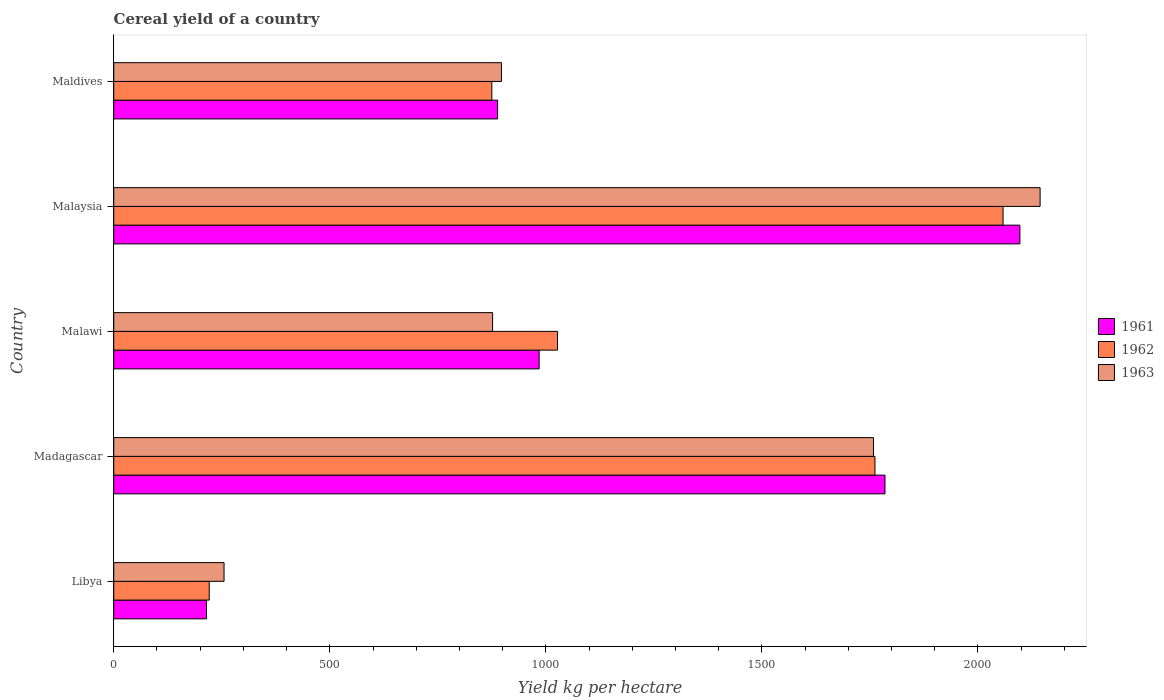How many groups of bars are there?
Make the answer very short. 5. How many bars are there on the 3rd tick from the top?
Offer a very short reply. 3. How many bars are there on the 5th tick from the bottom?
Your response must be concise. 3. What is the label of the 5th group of bars from the top?
Offer a terse response. Libya. In how many cases, is the number of bars for a given country not equal to the number of legend labels?
Provide a succinct answer. 0. What is the total cereal yield in 1962 in Maldives?
Ensure brevity in your answer.  875. Across all countries, what is the maximum total cereal yield in 1962?
Provide a short and direct response. 2058.06. Across all countries, what is the minimum total cereal yield in 1963?
Offer a very short reply. 255.27. In which country was the total cereal yield in 1962 maximum?
Give a very brief answer. Malaysia. In which country was the total cereal yield in 1961 minimum?
Ensure brevity in your answer.  Libya. What is the total total cereal yield in 1962 in the graph?
Your response must be concise. 5942.66. What is the difference between the total cereal yield in 1962 in Libya and that in Malaysia?
Offer a terse response. -1837.1. What is the difference between the total cereal yield in 1963 in Malawi and the total cereal yield in 1962 in Libya?
Your answer should be compact. 655.77. What is the average total cereal yield in 1962 per country?
Give a very brief answer. 1188.53. What is the difference between the total cereal yield in 1961 and total cereal yield in 1962 in Maldives?
Make the answer very short. 13.27. What is the ratio of the total cereal yield in 1962 in Libya to that in Maldives?
Make the answer very short. 0.25. Is the difference between the total cereal yield in 1961 in Madagascar and Maldives greater than the difference between the total cereal yield in 1962 in Madagascar and Maldives?
Ensure brevity in your answer.  Yes. What is the difference between the highest and the second highest total cereal yield in 1963?
Offer a terse response. 385.6. What is the difference between the highest and the lowest total cereal yield in 1963?
Keep it short and to the point. 1888.54. In how many countries, is the total cereal yield in 1963 greater than the average total cereal yield in 1963 taken over all countries?
Offer a very short reply. 2. Are all the bars in the graph horizontal?
Offer a terse response. Yes. How many countries are there in the graph?
Give a very brief answer. 5. What is the difference between two consecutive major ticks on the X-axis?
Your answer should be compact. 500. Does the graph contain any zero values?
Make the answer very short. No. Does the graph contain grids?
Offer a terse response. No. How many legend labels are there?
Keep it short and to the point. 3. What is the title of the graph?
Ensure brevity in your answer.  Cereal yield of a country. Does "1985" appear as one of the legend labels in the graph?
Your answer should be very brief. No. What is the label or title of the X-axis?
Keep it short and to the point. Yield kg per hectare. What is the Yield kg per hectare of 1961 in Libya?
Provide a succinct answer. 214.71. What is the Yield kg per hectare of 1962 in Libya?
Make the answer very short. 220.96. What is the Yield kg per hectare of 1963 in Libya?
Your response must be concise. 255.27. What is the Yield kg per hectare of 1961 in Madagascar?
Offer a terse response. 1784.82. What is the Yield kg per hectare in 1962 in Madagascar?
Your response must be concise. 1761.64. What is the Yield kg per hectare in 1963 in Madagascar?
Provide a succinct answer. 1758.21. What is the Yield kg per hectare in 1961 in Malawi?
Make the answer very short. 984.46. What is the Yield kg per hectare in 1962 in Malawi?
Offer a very short reply. 1027. What is the Yield kg per hectare of 1963 in Malawi?
Make the answer very short. 876.73. What is the Yield kg per hectare of 1961 in Malaysia?
Your response must be concise. 2097.04. What is the Yield kg per hectare of 1962 in Malaysia?
Make the answer very short. 2058.06. What is the Yield kg per hectare in 1963 in Malaysia?
Make the answer very short. 2143.81. What is the Yield kg per hectare in 1961 in Maldives?
Offer a terse response. 888.27. What is the Yield kg per hectare in 1962 in Maldives?
Provide a succinct answer. 875. What is the Yield kg per hectare of 1963 in Maldives?
Your answer should be very brief. 897.26. Across all countries, what is the maximum Yield kg per hectare of 1961?
Provide a succinct answer. 2097.04. Across all countries, what is the maximum Yield kg per hectare in 1962?
Keep it short and to the point. 2058.06. Across all countries, what is the maximum Yield kg per hectare of 1963?
Your response must be concise. 2143.81. Across all countries, what is the minimum Yield kg per hectare of 1961?
Ensure brevity in your answer.  214.71. Across all countries, what is the minimum Yield kg per hectare of 1962?
Provide a short and direct response. 220.96. Across all countries, what is the minimum Yield kg per hectare in 1963?
Keep it short and to the point. 255.27. What is the total Yield kg per hectare of 1961 in the graph?
Offer a very short reply. 5969.3. What is the total Yield kg per hectare of 1962 in the graph?
Provide a succinct answer. 5942.66. What is the total Yield kg per hectare of 1963 in the graph?
Keep it short and to the point. 5931.27. What is the difference between the Yield kg per hectare in 1961 in Libya and that in Madagascar?
Provide a short and direct response. -1570.11. What is the difference between the Yield kg per hectare in 1962 in Libya and that in Madagascar?
Your answer should be compact. -1540.68. What is the difference between the Yield kg per hectare in 1963 in Libya and that in Madagascar?
Keep it short and to the point. -1502.94. What is the difference between the Yield kg per hectare of 1961 in Libya and that in Malawi?
Keep it short and to the point. -769.75. What is the difference between the Yield kg per hectare of 1962 in Libya and that in Malawi?
Make the answer very short. -806.04. What is the difference between the Yield kg per hectare in 1963 in Libya and that in Malawi?
Ensure brevity in your answer.  -621.46. What is the difference between the Yield kg per hectare of 1961 in Libya and that in Malaysia?
Offer a very short reply. -1882.34. What is the difference between the Yield kg per hectare of 1962 in Libya and that in Malaysia?
Keep it short and to the point. -1837.11. What is the difference between the Yield kg per hectare of 1963 in Libya and that in Malaysia?
Offer a terse response. -1888.54. What is the difference between the Yield kg per hectare of 1961 in Libya and that in Maldives?
Provide a succinct answer. -673.56. What is the difference between the Yield kg per hectare of 1962 in Libya and that in Maldives?
Keep it short and to the point. -654.04. What is the difference between the Yield kg per hectare of 1963 in Libya and that in Maldives?
Your answer should be compact. -641.99. What is the difference between the Yield kg per hectare of 1961 in Madagascar and that in Malawi?
Keep it short and to the point. 800.36. What is the difference between the Yield kg per hectare in 1962 in Madagascar and that in Malawi?
Your answer should be compact. 734.64. What is the difference between the Yield kg per hectare of 1963 in Madagascar and that in Malawi?
Make the answer very short. 881.48. What is the difference between the Yield kg per hectare of 1961 in Madagascar and that in Malaysia?
Your response must be concise. -312.22. What is the difference between the Yield kg per hectare in 1962 in Madagascar and that in Malaysia?
Provide a succinct answer. -296.43. What is the difference between the Yield kg per hectare in 1963 in Madagascar and that in Malaysia?
Provide a short and direct response. -385.6. What is the difference between the Yield kg per hectare of 1961 in Madagascar and that in Maldives?
Offer a terse response. 896.55. What is the difference between the Yield kg per hectare in 1962 in Madagascar and that in Maldives?
Keep it short and to the point. 886.64. What is the difference between the Yield kg per hectare in 1963 in Madagascar and that in Maldives?
Provide a short and direct response. 860.95. What is the difference between the Yield kg per hectare of 1961 in Malawi and that in Malaysia?
Provide a short and direct response. -1112.58. What is the difference between the Yield kg per hectare in 1962 in Malawi and that in Malaysia?
Make the answer very short. -1031.07. What is the difference between the Yield kg per hectare of 1963 in Malawi and that in Malaysia?
Ensure brevity in your answer.  -1267.08. What is the difference between the Yield kg per hectare of 1961 in Malawi and that in Maldives?
Make the answer very short. 96.19. What is the difference between the Yield kg per hectare in 1962 in Malawi and that in Maldives?
Your response must be concise. 152. What is the difference between the Yield kg per hectare of 1963 in Malawi and that in Maldives?
Your response must be concise. -20.53. What is the difference between the Yield kg per hectare in 1961 in Malaysia and that in Maldives?
Offer a very short reply. 1208.78. What is the difference between the Yield kg per hectare of 1962 in Malaysia and that in Maldives?
Your response must be concise. 1183.06. What is the difference between the Yield kg per hectare of 1963 in Malaysia and that in Maldives?
Your answer should be very brief. 1246.55. What is the difference between the Yield kg per hectare in 1961 in Libya and the Yield kg per hectare in 1962 in Madagascar?
Your answer should be compact. -1546.93. What is the difference between the Yield kg per hectare in 1961 in Libya and the Yield kg per hectare in 1963 in Madagascar?
Provide a short and direct response. -1543.5. What is the difference between the Yield kg per hectare in 1962 in Libya and the Yield kg per hectare in 1963 in Madagascar?
Offer a terse response. -1537.25. What is the difference between the Yield kg per hectare of 1961 in Libya and the Yield kg per hectare of 1962 in Malawi?
Offer a very short reply. -812.29. What is the difference between the Yield kg per hectare in 1961 in Libya and the Yield kg per hectare in 1963 in Malawi?
Keep it short and to the point. -662.02. What is the difference between the Yield kg per hectare in 1962 in Libya and the Yield kg per hectare in 1963 in Malawi?
Offer a terse response. -655.77. What is the difference between the Yield kg per hectare in 1961 in Libya and the Yield kg per hectare in 1962 in Malaysia?
Ensure brevity in your answer.  -1843.36. What is the difference between the Yield kg per hectare in 1961 in Libya and the Yield kg per hectare in 1963 in Malaysia?
Provide a succinct answer. -1929.1. What is the difference between the Yield kg per hectare in 1962 in Libya and the Yield kg per hectare in 1963 in Malaysia?
Provide a succinct answer. -1922.85. What is the difference between the Yield kg per hectare of 1961 in Libya and the Yield kg per hectare of 1962 in Maldives?
Provide a short and direct response. -660.29. What is the difference between the Yield kg per hectare of 1961 in Libya and the Yield kg per hectare of 1963 in Maldives?
Provide a succinct answer. -682.55. What is the difference between the Yield kg per hectare of 1962 in Libya and the Yield kg per hectare of 1963 in Maldives?
Offer a terse response. -676.3. What is the difference between the Yield kg per hectare in 1961 in Madagascar and the Yield kg per hectare in 1962 in Malawi?
Offer a very short reply. 757.82. What is the difference between the Yield kg per hectare of 1961 in Madagascar and the Yield kg per hectare of 1963 in Malawi?
Offer a terse response. 908.09. What is the difference between the Yield kg per hectare in 1962 in Madagascar and the Yield kg per hectare in 1963 in Malawi?
Provide a succinct answer. 884.91. What is the difference between the Yield kg per hectare of 1961 in Madagascar and the Yield kg per hectare of 1962 in Malaysia?
Your answer should be very brief. -273.24. What is the difference between the Yield kg per hectare of 1961 in Madagascar and the Yield kg per hectare of 1963 in Malaysia?
Your answer should be very brief. -358.99. What is the difference between the Yield kg per hectare of 1962 in Madagascar and the Yield kg per hectare of 1963 in Malaysia?
Keep it short and to the point. -382.17. What is the difference between the Yield kg per hectare of 1961 in Madagascar and the Yield kg per hectare of 1962 in Maldives?
Your answer should be very brief. 909.82. What is the difference between the Yield kg per hectare of 1961 in Madagascar and the Yield kg per hectare of 1963 in Maldives?
Provide a short and direct response. 887.56. What is the difference between the Yield kg per hectare in 1962 in Madagascar and the Yield kg per hectare in 1963 in Maldives?
Your answer should be very brief. 864.38. What is the difference between the Yield kg per hectare of 1961 in Malawi and the Yield kg per hectare of 1962 in Malaysia?
Keep it short and to the point. -1073.6. What is the difference between the Yield kg per hectare in 1961 in Malawi and the Yield kg per hectare in 1963 in Malaysia?
Your answer should be compact. -1159.35. What is the difference between the Yield kg per hectare in 1962 in Malawi and the Yield kg per hectare in 1963 in Malaysia?
Make the answer very short. -1116.81. What is the difference between the Yield kg per hectare of 1961 in Malawi and the Yield kg per hectare of 1962 in Maldives?
Provide a succinct answer. 109.46. What is the difference between the Yield kg per hectare of 1961 in Malawi and the Yield kg per hectare of 1963 in Maldives?
Your answer should be very brief. 87.2. What is the difference between the Yield kg per hectare in 1962 in Malawi and the Yield kg per hectare in 1963 in Maldives?
Your response must be concise. 129.74. What is the difference between the Yield kg per hectare in 1961 in Malaysia and the Yield kg per hectare in 1962 in Maldives?
Give a very brief answer. 1222.04. What is the difference between the Yield kg per hectare of 1961 in Malaysia and the Yield kg per hectare of 1963 in Maldives?
Provide a succinct answer. 1199.78. What is the difference between the Yield kg per hectare of 1962 in Malaysia and the Yield kg per hectare of 1963 in Maldives?
Keep it short and to the point. 1160.8. What is the average Yield kg per hectare of 1961 per country?
Provide a short and direct response. 1193.86. What is the average Yield kg per hectare in 1962 per country?
Your answer should be very brief. 1188.53. What is the average Yield kg per hectare in 1963 per country?
Offer a very short reply. 1186.26. What is the difference between the Yield kg per hectare of 1961 and Yield kg per hectare of 1962 in Libya?
Make the answer very short. -6.25. What is the difference between the Yield kg per hectare in 1961 and Yield kg per hectare in 1963 in Libya?
Ensure brevity in your answer.  -40.56. What is the difference between the Yield kg per hectare in 1962 and Yield kg per hectare in 1963 in Libya?
Offer a very short reply. -34.31. What is the difference between the Yield kg per hectare of 1961 and Yield kg per hectare of 1962 in Madagascar?
Offer a terse response. 23.18. What is the difference between the Yield kg per hectare in 1961 and Yield kg per hectare in 1963 in Madagascar?
Provide a succinct answer. 26.61. What is the difference between the Yield kg per hectare of 1962 and Yield kg per hectare of 1963 in Madagascar?
Make the answer very short. 3.43. What is the difference between the Yield kg per hectare of 1961 and Yield kg per hectare of 1962 in Malawi?
Your answer should be very brief. -42.53. What is the difference between the Yield kg per hectare of 1961 and Yield kg per hectare of 1963 in Malawi?
Provide a short and direct response. 107.73. What is the difference between the Yield kg per hectare of 1962 and Yield kg per hectare of 1963 in Malawi?
Offer a very short reply. 150.27. What is the difference between the Yield kg per hectare of 1961 and Yield kg per hectare of 1962 in Malaysia?
Offer a very short reply. 38.98. What is the difference between the Yield kg per hectare of 1961 and Yield kg per hectare of 1963 in Malaysia?
Offer a terse response. -46.76. What is the difference between the Yield kg per hectare in 1962 and Yield kg per hectare in 1963 in Malaysia?
Your answer should be compact. -85.74. What is the difference between the Yield kg per hectare of 1961 and Yield kg per hectare of 1962 in Maldives?
Your answer should be compact. 13.27. What is the difference between the Yield kg per hectare of 1961 and Yield kg per hectare of 1963 in Maldives?
Make the answer very short. -8.99. What is the difference between the Yield kg per hectare in 1962 and Yield kg per hectare in 1963 in Maldives?
Give a very brief answer. -22.26. What is the ratio of the Yield kg per hectare in 1961 in Libya to that in Madagascar?
Offer a very short reply. 0.12. What is the ratio of the Yield kg per hectare of 1962 in Libya to that in Madagascar?
Offer a very short reply. 0.13. What is the ratio of the Yield kg per hectare of 1963 in Libya to that in Madagascar?
Offer a very short reply. 0.15. What is the ratio of the Yield kg per hectare in 1961 in Libya to that in Malawi?
Make the answer very short. 0.22. What is the ratio of the Yield kg per hectare of 1962 in Libya to that in Malawi?
Your answer should be compact. 0.22. What is the ratio of the Yield kg per hectare of 1963 in Libya to that in Malawi?
Make the answer very short. 0.29. What is the ratio of the Yield kg per hectare of 1961 in Libya to that in Malaysia?
Your answer should be compact. 0.1. What is the ratio of the Yield kg per hectare of 1962 in Libya to that in Malaysia?
Provide a short and direct response. 0.11. What is the ratio of the Yield kg per hectare in 1963 in Libya to that in Malaysia?
Your answer should be very brief. 0.12. What is the ratio of the Yield kg per hectare of 1961 in Libya to that in Maldives?
Offer a terse response. 0.24. What is the ratio of the Yield kg per hectare in 1962 in Libya to that in Maldives?
Your response must be concise. 0.25. What is the ratio of the Yield kg per hectare in 1963 in Libya to that in Maldives?
Offer a very short reply. 0.28. What is the ratio of the Yield kg per hectare in 1961 in Madagascar to that in Malawi?
Your answer should be compact. 1.81. What is the ratio of the Yield kg per hectare of 1962 in Madagascar to that in Malawi?
Provide a succinct answer. 1.72. What is the ratio of the Yield kg per hectare in 1963 in Madagascar to that in Malawi?
Make the answer very short. 2.01. What is the ratio of the Yield kg per hectare of 1961 in Madagascar to that in Malaysia?
Give a very brief answer. 0.85. What is the ratio of the Yield kg per hectare in 1962 in Madagascar to that in Malaysia?
Your response must be concise. 0.86. What is the ratio of the Yield kg per hectare in 1963 in Madagascar to that in Malaysia?
Offer a terse response. 0.82. What is the ratio of the Yield kg per hectare in 1961 in Madagascar to that in Maldives?
Make the answer very short. 2.01. What is the ratio of the Yield kg per hectare in 1962 in Madagascar to that in Maldives?
Provide a succinct answer. 2.01. What is the ratio of the Yield kg per hectare of 1963 in Madagascar to that in Maldives?
Provide a short and direct response. 1.96. What is the ratio of the Yield kg per hectare in 1961 in Malawi to that in Malaysia?
Your answer should be very brief. 0.47. What is the ratio of the Yield kg per hectare of 1962 in Malawi to that in Malaysia?
Your answer should be very brief. 0.5. What is the ratio of the Yield kg per hectare in 1963 in Malawi to that in Malaysia?
Your response must be concise. 0.41. What is the ratio of the Yield kg per hectare in 1961 in Malawi to that in Maldives?
Ensure brevity in your answer.  1.11. What is the ratio of the Yield kg per hectare in 1962 in Malawi to that in Maldives?
Your response must be concise. 1.17. What is the ratio of the Yield kg per hectare of 1963 in Malawi to that in Maldives?
Your answer should be compact. 0.98. What is the ratio of the Yield kg per hectare in 1961 in Malaysia to that in Maldives?
Make the answer very short. 2.36. What is the ratio of the Yield kg per hectare of 1962 in Malaysia to that in Maldives?
Your response must be concise. 2.35. What is the ratio of the Yield kg per hectare in 1963 in Malaysia to that in Maldives?
Offer a terse response. 2.39. What is the difference between the highest and the second highest Yield kg per hectare in 1961?
Your answer should be very brief. 312.22. What is the difference between the highest and the second highest Yield kg per hectare in 1962?
Make the answer very short. 296.43. What is the difference between the highest and the second highest Yield kg per hectare in 1963?
Provide a short and direct response. 385.6. What is the difference between the highest and the lowest Yield kg per hectare in 1961?
Keep it short and to the point. 1882.34. What is the difference between the highest and the lowest Yield kg per hectare of 1962?
Your answer should be compact. 1837.11. What is the difference between the highest and the lowest Yield kg per hectare of 1963?
Give a very brief answer. 1888.54. 